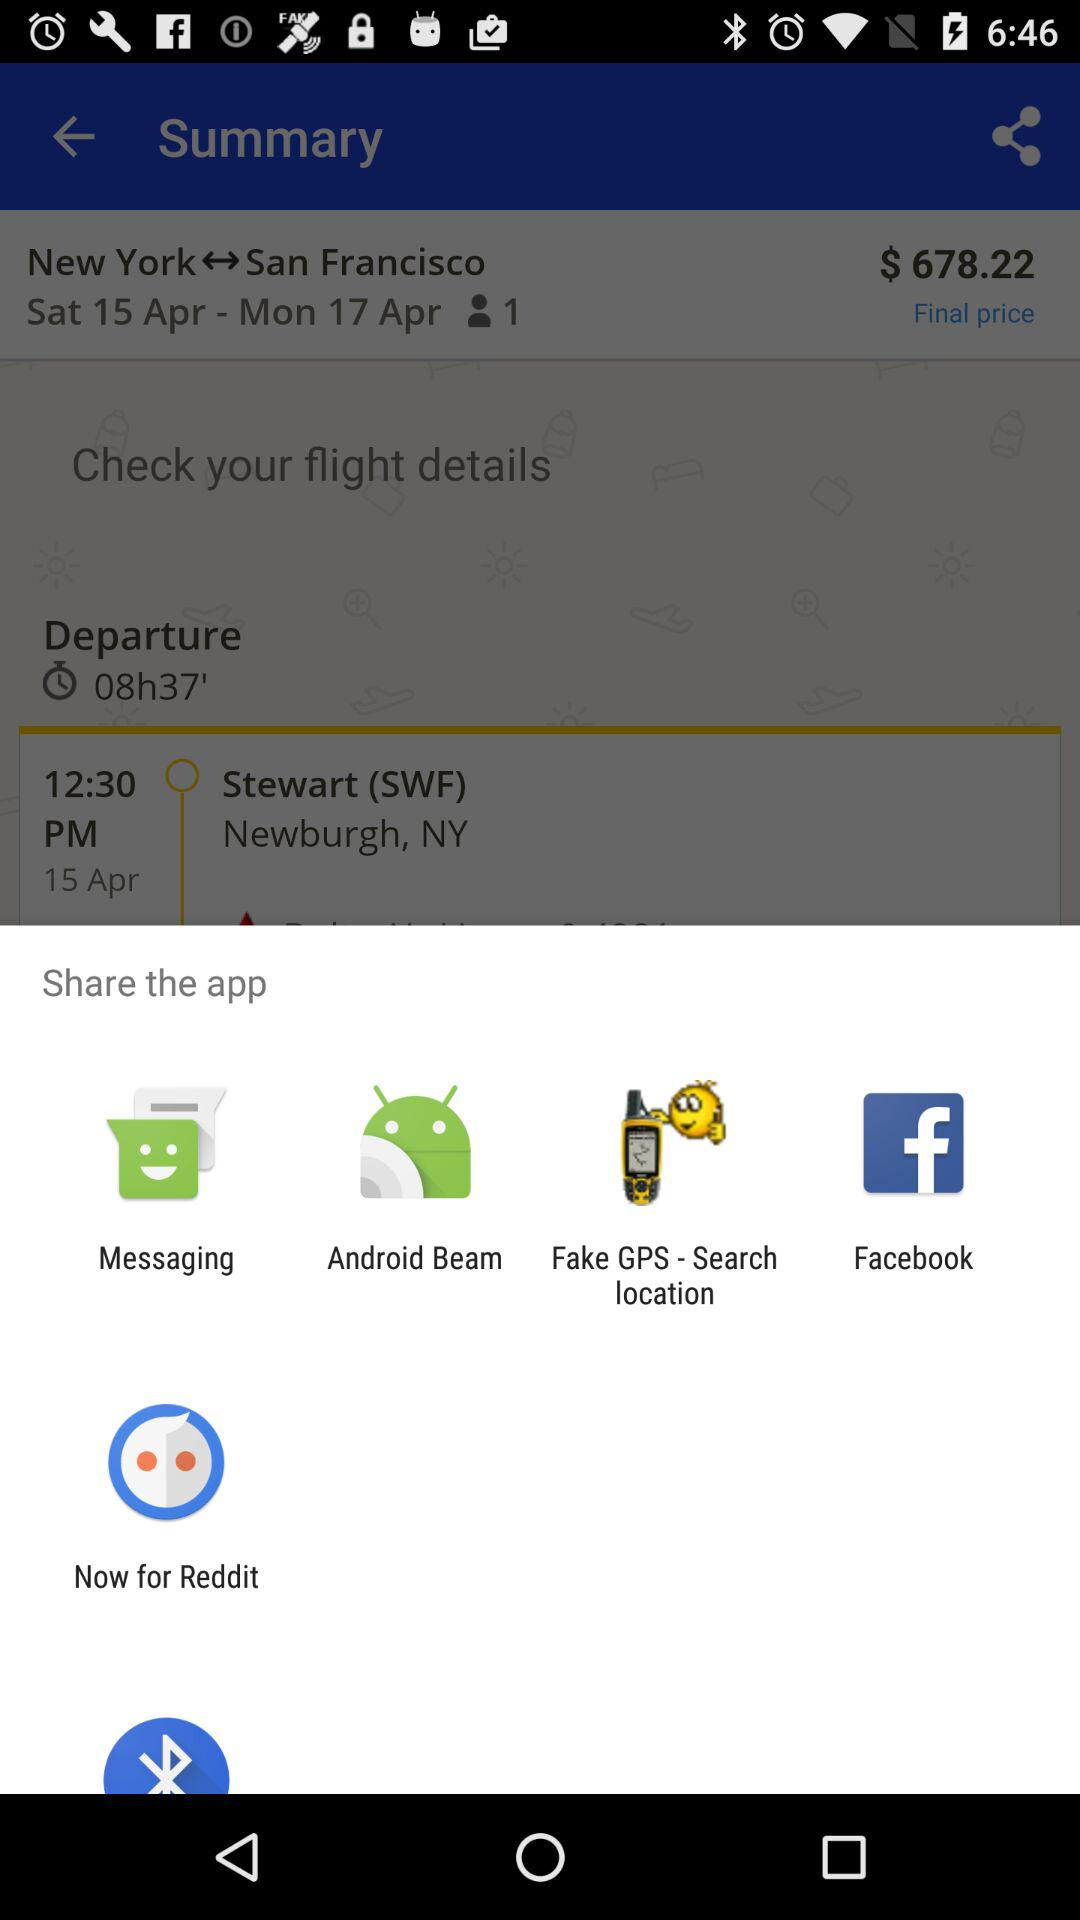What is the departure date for the San Francisco flight? The departure date is Saturday, April 15. 